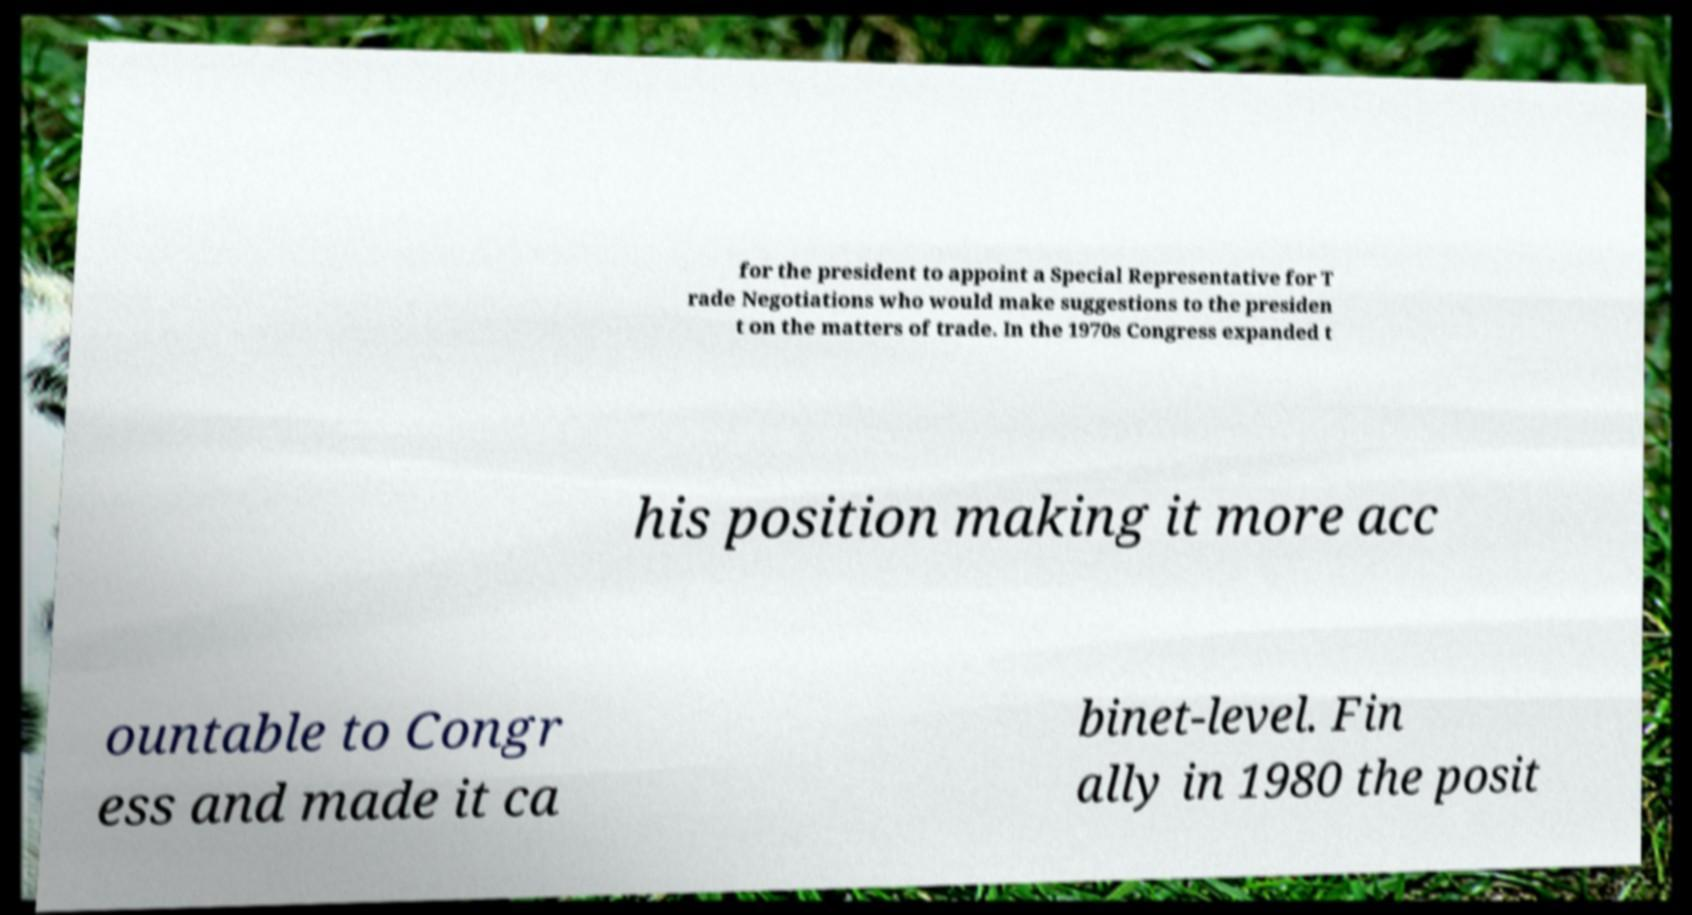There's text embedded in this image that I need extracted. Can you transcribe it verbatim? for the president to appoint a Special Representative for T rade Negotiations who would make suggestions to the presiden t on the matters of trade. In the 1970s Congress expanded t his position making it more acc ountable to Congr ess and made it ca binet-level. Fin ally in 1980 the posit 